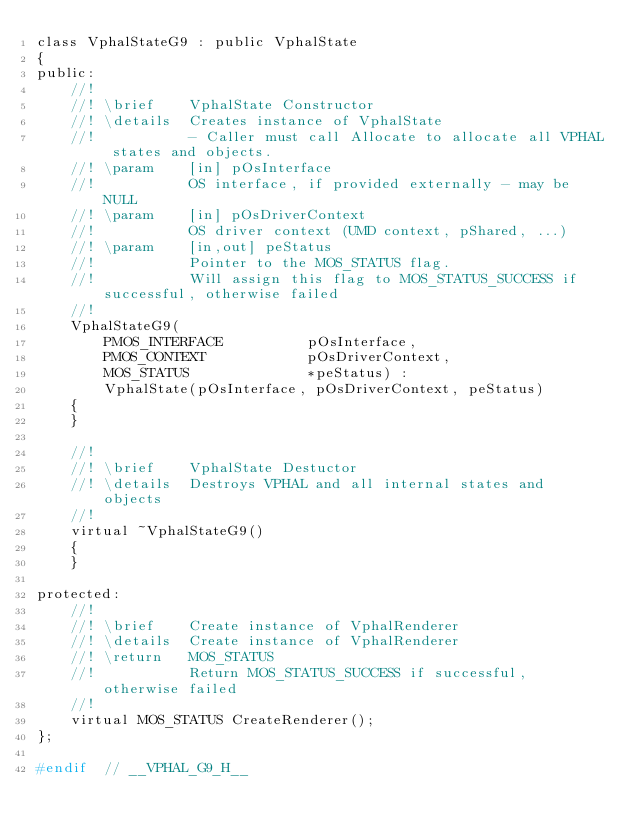<code> <loc_0><loc_0><loc_500><loc_500><_C_>class VphalStateG9 : public VphalState
{
public:
    //!
    //! \brief    VphalState Constructor
    //! \details  Creates instance of VphalState
    //!           - Caller must call Allocate to allocate all VPHAL states and objects.
    //! \param    [in] pOsInterface
    //!           OS interface, if provided externally - may be NULL
    //! \param    [in] pOsDriverContext
    //!           OS driver context (UMD context, pShared, ...)
    //! \param    [in,out] peStatus
    //!           Pointer to the MOS_STATUS flag.
    //!           Will assign this flag to MOS_STATUS_SUCCESS if successful, otherwise failed
    //!
    VphalStateG9(
        PMOS_INTERFACE          pOsInterface,
        PMOS_CONTEXT            pOsDriverContext,
        MOS_STATUS              *peStatus) :
        VphalState(pOsInterface, pOsDriverContext, peStatus)
    {
    }

    //!
    //! \brief    VphalState Destuctor
    //! \details  Destroys VPHAL and all internal states and objects
    //!
    virtual ~VphalStateG9()
    {
    }

protected:
    //!
    //! \brief    Create instance of VphalRenderer
    //! \details  Create instance of VphalRenderer
    //! \return   MOS_STATUS
    //!           Return MOS_STATUS_SUCCESS if successful, otherwise failed
    //!
    virtual MOS_STATUS CreateRenderer();
};

#endif  // __VPHAL_G9_H__
</code> 